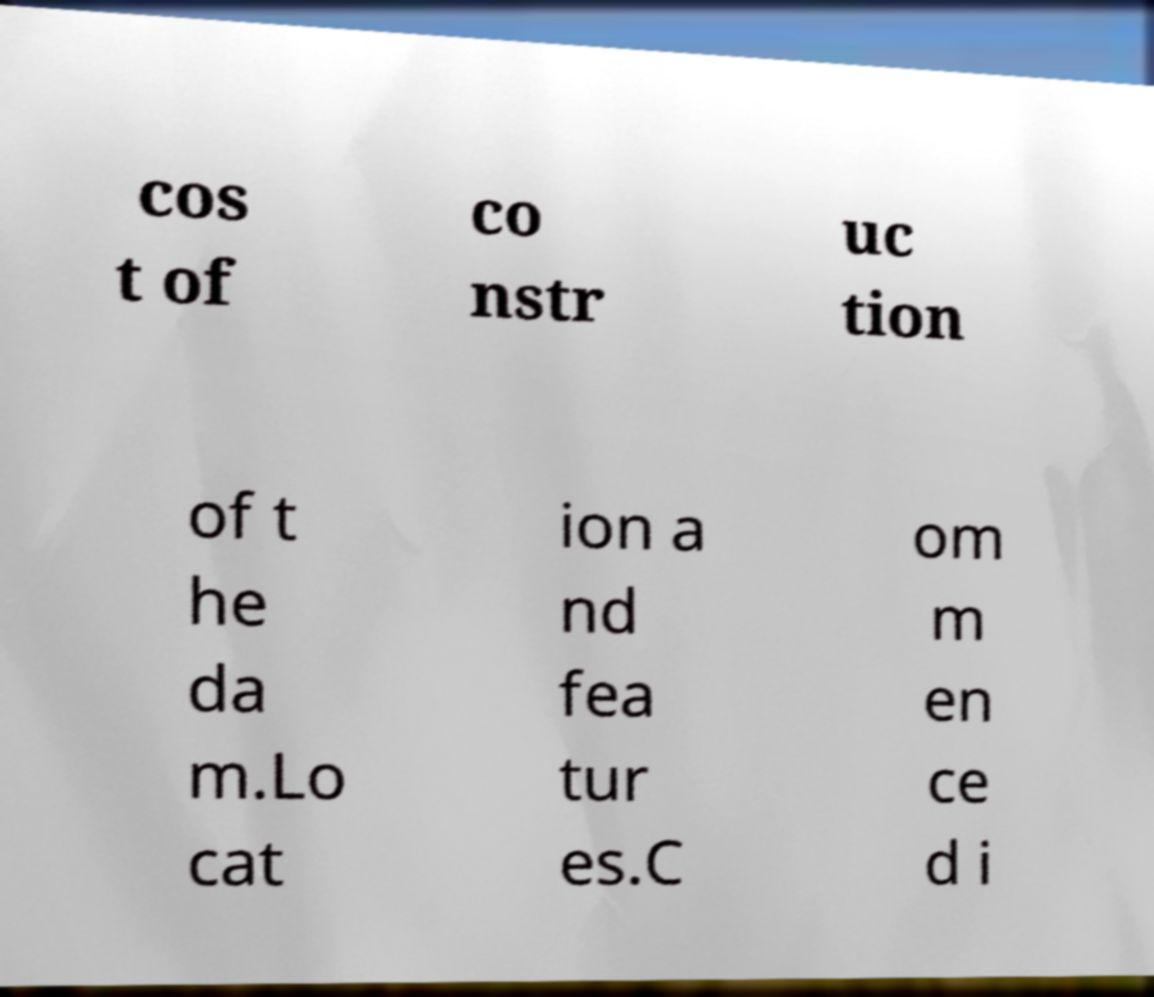There's text embedded in this image that I need extracted. Can you transcribe it verbatim? cos t of co nstr uc tion of t he da m.Lo cat ion a nd fea tur es.C om m en ce d i 